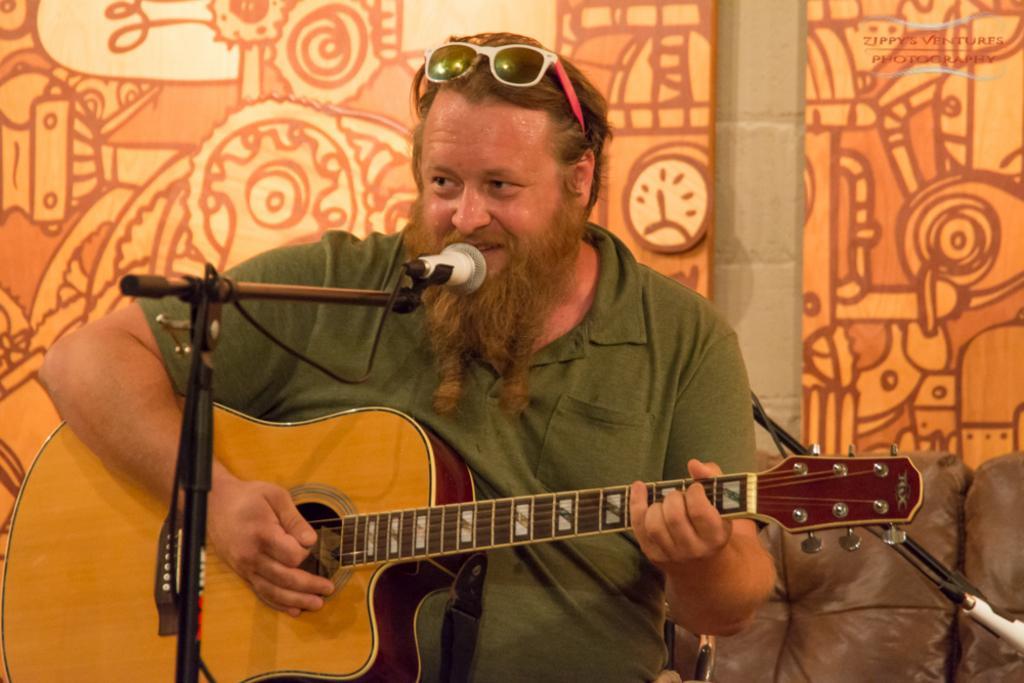How would you summarize this image in a sentence or two? There is a man sitting. He is wearing a green color t-shirt. In front of him there is a mic. He playing a guitar. 